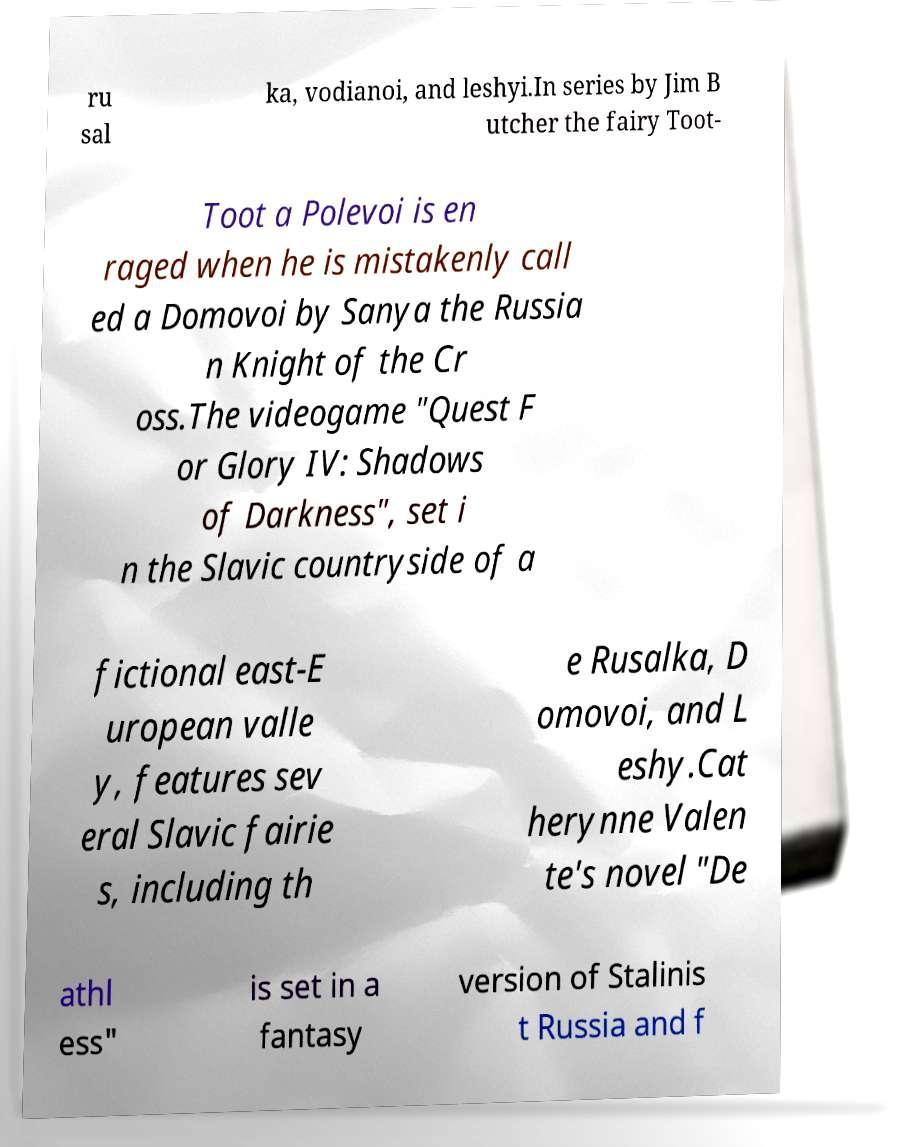Could you assist in decoding the text presented in this image and type it out clearly? ru sal ka, vodianoi, and leshyi.In series by Jim B utcher the fairy Toot- Toot a Polevoi is en raged when he is mistakenly call ed a Domovoi by Sanya the Russia n Knight of the Cr oss.The videogame "Quest F or Glory IV: Shadows of Darkness", set i n the Slavic countryside of a fictional east-E uropean valle y, features sev eral Slavic fairie s, including th e Rusalka, D omovoi, and L eshy.Cat herynne Valen te's novel "De athl ess" is set in a fantasy version of Stalinis t Russia and f 